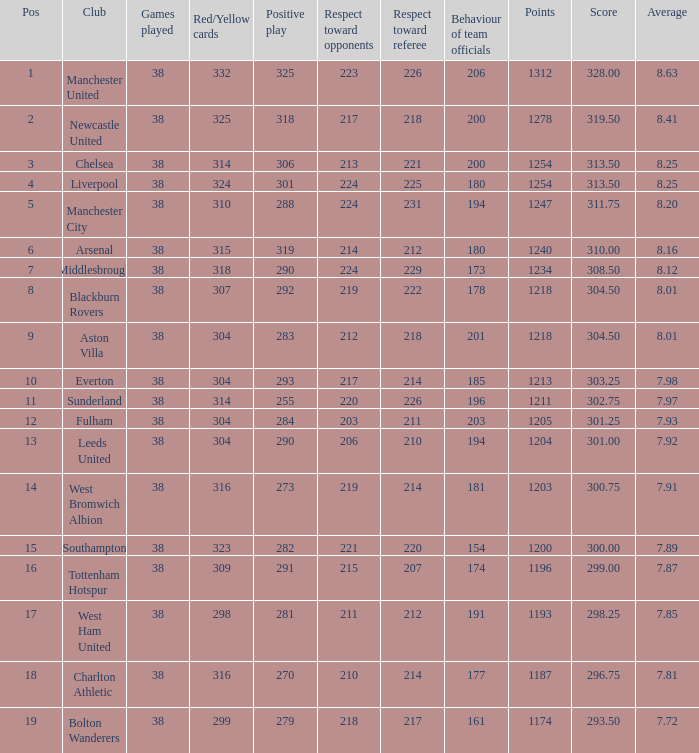Parse the full table. {'header': ['Pos', 'Club', 'Games played', 'Red/Yellow cards', 'Positive play', 'Respect toward opponents', 'Respect toward referee', 'Behaviour of team officials', 'Points', 'Score', 'Average'], 'rows': [['1', 'Manchester United', '38', '332', '325', '223', '226', '206', '1312', '328.00', '8.63'], ['2', 'Newcastle United', '38', '325', '318', '217', '218', '200', '1278', '319.50', '8.41'], ['3', 'Chelsea', '38', '314', '306', '213', '221', '200', '1254', '313.50', '8.25'], ['4', 'Liverpool', '38', '324', '301', '224', '225', '180', '1254', '313.50', '8.25'], ['5', 'Manchester City', '38', '310', '288', '224', '231', '194', '1247', '311.75', '8.20'], ['6', 'Arsenal', '38', '315', '319', '214', '212', '180', '1240', '310.00', '8.16'], ['7', 'Middlesbrough', '38', '318', '290', '224', '229', '173', '1234', '308.50', '8.12'], ['8', 'Blackburn Rovers', '38', '307', '292', '219', '222', '178', '1218', '304.50', '8.01'], ['9', 'Aston Villa', '38', '304', '283', '212', '218', '201', '1218', '304.50', '8.01'], ['10', 'Everton', '38', '304', '293', '217', '214', '185', '1213', '303.25', '7.98'], ['11', 'Sunderland', '38', '314', '255', '220', '226', '196', '1211', '302.75', '7.97'], ['12', 'Fulham', '38', '304', '284', '203', '211', '203', '1205', '301.25', '7.93'], ['13', 'Leeds United', '38', '304', '290', '206', '210', '194', '1204', '301.00', '7.92'], ['14', 'West Bromwich Albion', '38', '316', '273', '219', '214', '181', '1203', '300.75', '7.91'], ['15', 'Southampton', '38', '323', '282', '221', '220', '154', '1200', '300.00', '7.89'], ['16', 'Tottenham Hotspur', '38', '309', '291', '215', '207', '174', '1196', '299.00', '7.87'], ['17', 'West Ham United', '38', '298', '281', '211', '212', '191', '1193', '298.25', '7.85'], ['18', 'Charlton Athletic', '38', '316', '270', '210', '214', '177', '1187', '296.75', '7.81'], ['19', 'Bolton Wanderers', '38', '299', '279', '218', '217', '161', '1174', '293.50', '7.72']]} Name the points for 212 respect toward opponents 1218.0. 